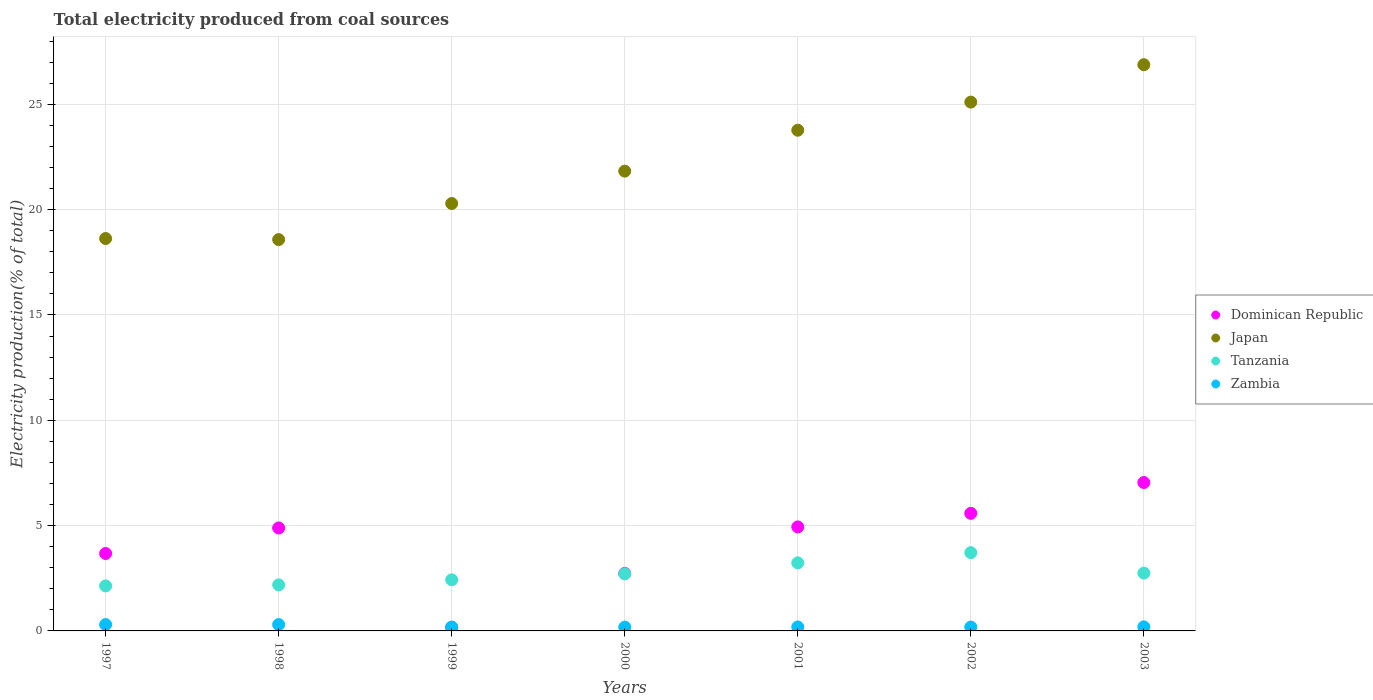How many different coloured dotlines are there?
Give a very brief answer. 4. Is the number of dotlines equal to the number of legend labels?
Provide a short and direct response. Yes. What is the total electricity produced in Dominican Republic in 1997?
Your response must be concise. 3.68. Across all years, what is the maximum total electricity produced in Dominican Republic?
Keep it short and to the point. 7.05. Across all years, what is the minimum total electricity produced in Zambia?
Your response must be concise. 0.18. What is the total total electricity produced in Dominican Republic in the graph?
Your answer should be very brief. 29.03. What is the difference between the total electricity produced in Dominican Republic in 1998 and that in 1999?
Give a very brief answer. 4.72. What is the difference between the total electricity produced in Zambia in 2002 and the total electricity produced in Japan in 2000?
Provide a short and direct response. -21.64. What is the average total electricity produced in Dominican Republic per year?
Offer a terse response. 4.15. In the year 2003, what is the difference between the total electricity produced in Zambia and total electricity produced in Dominican Republic?
Make the answer very short. -6.85. What is the ratio of the total electricity produced in Tanzania in 1998 to that in 2002?
Your answer should be very brief. 0.59. What is the difference between the highest and the second highest total electricity produced in Dominican Republic?
Ensure brevity in your answer.  1.46. What is the difference between the highest and the lowest total electricity produced in Tanzania?
Offer a very short reply. 1.58. Is the sum of the total electricity produced in Japan in 1998 and 2001 greater than the maximum total electricity produced in Tanzania across all years?
Your response must be concise. Yes. Is it the case that in every year, the sum of the total electricity produced in Tanzania and total electricity produced in Dominican Republic  is greater than the sum of total electricity produced in Zambia and total electricity produced in Japan?
Offer a very short reply. No. Is it the case that in every year, the sum of the total electricity produced in Dominican Republic and total electricity produced in Zambia  is greater than the total electricity produced in Tanzania?
Ensure brevity in your answer.  No. Is the total electricity produced in Tanzania strictly less than the total electricity produced in Dominican Republic over the years?
Offer a terse response. No. What is the difference between two consecutive major ticks on the Y-axis?
Your response must be concise. 5. Are the values on the major ticks of Y-axis written in scientific E-notation?
Offer a very short reply. No. Does the graph contain any zero values?
Your response must be concise. No. Does the graph contain grids?
Provide a succinct answer. Yes. How many legend labels are there?
Offer a very short reply. 4. How are the legend labels stacked?
Provide a short and direct response. Vertical. What is the title of the graph?
Offer a terse response. Total electricity produced from coal sources. Does "West Bank and Gaza" appear as one of the legend labels in the graph?
Give a very brief answer. No. What is the label or title of the X-axis?
Your response must be concise. Years. What is the label or title of the Y-axis?
Provide a succinct answer. Electricity production(% of total). What is the Electricity production(% of total) of Dominican Republic in 1997?
Provide a short and direct response. 3.68. What is the Electricity production(% of total) in Japan in 1997?
Keep it short and to the point. 18.63. What is the Electricity production(% of total) in Tanzania in 1997?
Keep it short and to the point. 2.14. What is the Electricity production(% of total) of Zambia in 1997?
Provide a short and direct response. 0.3. What is the Electricity production(% of total) of Dominican Republic in 1998?
Ensure brevity in your answer.  4.89. What is the Electricity production(% of total) of Japan in 1998?
Your answer should be very brief. 18.58. What is the Electricity production(% of total) in Tanzania in 1998?
Provide a succinct answer. 2.19. What is the Electricity production(% of total) of Zambia in 1998?
Provide a short and direct response. 0.3. What is the Electricity production(% of total) of Dominican Republic in 1999?
Offer a terse response. 0.17. What is the Electricity production(% of total) in Japan in 1999?
Offer a very short reply. 20.29. What is the Electricity production(% of total) in Tanzania in 1999?
Your answer should be compact. 2.43. What is the Electricity production(% of total) of Zambia in 1999?
Give a very brief answer. 0.18. What is the Electricity production(% of total) in Dominican Republic in 2000?
Make the answer very short. 2.73. What is the Electricity production(% of total) in Japan in 2000?
Keep it short and to the point. 21.83. What is the Electricity production(% of total) in Tanzania in 2000?
Offer a very short reply. 2.71. What is the Electricity production(% of total) of Zambia in 2000?
Give a very brief answer. 0.18. What is the Electricity production(% of total) in Dominican Republic in 2001?
Provide a succinct answer. 4.94. What is the Electricity production(% of total) of Japan in 2001?
Ensure brevity in your answer.  23.77. What is the Electricity production(% of total) in Tanzania in 2001?
Your answer should be very brief. 3.23. What is the Electricity production(% of total) of Zambia in 2001?
Provide a succinct answer. 0.19. What is the Electricity production(% of total) in Dominican Republic in 2002?
Your answer should be compact. 5.58. What is the Electricity production(% of total) in Japan in 2002?
Your response must be concise. 25.11. What is the Electricity production(% of total) of Tanzania in 2002?
Make the answer very short. 3.72. What is the Electricity production(% of total) of Zambia in 2002?
Provide a succinct answer. 0.18. What is the Electricity production(% of total) in Dominican Republic in 2003?
Give a very brief answer. 7.05. What is the Electricity production(% of total) of Japan in 2003?
Your answer should be very brief. 26.88. What is the Electricity production(% of total) in Tanzania in 2003?
Your response must be concise. 2.75. What is the Electricity production(% of total) of Zambia in 2003?
Offer a very short reply. 0.19. Across all years, what is the maximum Electricity production(% of total) of Dominican Republic?
Provide a succinct answer. 7.05. Across all years, what is the maximum Electricity production(% of total) in Japan?
Your answer should be compact. 26.88. Across all years, what is the maximum Electricity production(% of total) in Tanzania?
Provide a short and direct response. 3.72. Across all years, what is the maximum Electricity production(% of total) in Zambia?
Provide a short and direct response. 0.3. Across all years, what is the minimum Electricity production(% of total) in Dominican Republic?
Your answer should be compact. 0.17. Across all years, what is the minimum Electricity production(% of total) of Japan?
Provide a short and direct response. 18.58. Across all years, what is the minimum Electricity production(% of total) of Tanzania?
Provide a succinct answer. 2.14. Across all years, what is the minimum Electricity production(% of total) in Zambia?
Offer a very short reply. 0.18. What is the total Electricity production(% of total) of Dominican Republic in the graph?
Provide a succinct answer. 29.03. What is the total Electricity production(% of total) in Japan in the graph?
Your answer should be very brief. 155.08. What is the total Electricity production(% of total) of Tanzania in the graph?
Your answer should be very brief. 19.15. What is the total Electricity production(% of total) of Zambia in the graph?
Keep it short and to the point. 1.53. What is the difference between the Electricity production(% of total) of Dominican Republic in 1997 and that in 1998?
Make the answer very short. -1.21. What is the difference between the Electricity production(% of total) of Japan in 1997 and that in 1998?
Ensure brevity in your answer.  0.05. What is the difference between the Electricity production(% of total) in Tanzania in 1997 and that in 1998?
Your answer should be compact. -0.05. What is the difference between the Electricity production(% of total) in Zambia in 1997 and that in 1998?
Provide a succinct answer. -0. What is the difference between the Electricity production(% of total) of Dominican Republic in 1997 and that in 1999?
Offer a terse response. 3.51. What is the difference between the Electricity production(% of total) in Japan in 1997 and that in 1999?
Make the answer very short. -1.66. What is the difference between the Electricity production(% of total) of Tanzania in 1997 and that in 1999?
Give a very brief answer. -0.29. What is the difference between the Electricity production(% of total) in Zambia in 1997 and that in 1999?
Provide a succinct answer. 0.12. What is the difference between the Electricity production(% of total) in Dominican Republic in 1997 and that in 2000?
Give a very brief answer. 0.95. What is the difference between the Electricity production(% of total) in Japan in 1997 and that in 2000?
Offer a very short reply. -3.2. What is the difference between the Electricity production(% of total) of Tanzania in 1997 and that in 2000?
Your response must be concise. -0.57. What is the difference between the Electricity production(% of total) of Zambia in 1997 and that in 2000?
Your response must be concise. 0.12. What is the difference between the Electricity production(% of total) of Dominican Republic in 1997 and that in 2001?
Make the answer very short. -1.26. What is the difference between the Electricity production(% of total) of Japan in 1997 and that in 2001?
Ensure brevity in your answer.  -5.14. What is the difference between the Electricity production(% of total) of Tanzania in 1997 and that in 2001?
Give a very brief answer. -1.1. What is the difference between the Electricity production(% of total) in Zambia in 1997 and that in 2001?
Offer a very short reply. 0.11. What is the difference between the Electricity production(% of total) of Dominican Republic in 1997 and that in 2002?
Offer a terse response. -1.91. What is the difference between the Electricity production(% of total) of Japan in 1997 and that in 2002?
Offer a terse response. -6.48. What is the difference between the Electricity production(% of total) of Tanzania in 1997 and that in 2002?
Provide a short and direct response. -1.58. What is the difference between the Electricity production(% of total) in Zambia in 1997 and that in 2002?
Keep it short and to the point. 0.12. What is the difference between the Electricity production(% of total) in Dominican Republic in 1997 and that in 2003?
Your response must be concise. -3.37. What is the difference between the Electricity production(% of total) of Japan in 1997 and that in 2003?
Your response must be concise. -8.25. What is the difference between the Electricity production(% of total) of Tanzania in 1997 and that in 2003?
Ensure brevity in your answer.  -0.61. What is the difference between the Electricity production(% of total) in Zambia in 1997 and that in 2003?
Your answer should be compact. 0.11. What is the difference between the Electricity production(% of total) in Dominican Republic in 1998 and that in 1999?
Keep it short and to the point. 4.72. What is the difference between the Electricity production(% of total) of Japan in 1998 and that in 1999?
Ensure brevity in your answer.  -1.71. What is the difference between the Electricity production(% of total) in Tanzania in 1998 and that in 1999?
Ensure brevity in your answer.  -0.24. What is the difference between the Electricity production(% of total) in Zambia in 1998 and that in 1999?
Offer a very short reply. 0.12. What is the difference between the Electricity production(% of total) of Dominican Republic in 1998 and that in 2000?
Your answer should be very brief. 2.16. What is the difference between the Electricity production(% of total) of Japan in 1998 and that in 2000?
Keep it short and to the point. -3.25. What is the difference between the Electricity production(% of total) in Tanzania in 1998 and that in 2000?
Your response must be concise. -0.52. What is the difference between the Electricity production(% of total) of Zambia in 1998 and that in 2000?
Make the answer very short. 0.12. What is the difference between the Electricity production(% of total) in Dominican Republic in 1998 and that in 2001?
Your response must be concise. -0.05. What is the difference between the Electricity production(% of total) of Japan in 1998 and that in 2001?
Ensure brevity in your answer.  -5.19. What is the difference between the Electricity production(% of total) of Tanzania in 1998 and that in 2001?
Make the answer very short. -1.05. What is the difference between the Electricity production(% of total) in Zambia in 1998 and that in 2001?
Give a very brief answer. 0.11. What is the difference between the Electricity production(% of total) of Dominican Republic in 1998 and that in 2002?
Offer a terse response. -0.69. What is the difference between the Electricity production(% of total) in Japan in 1998 and that in 2002?
Offer a terse response. -6.53. What is the difference between the Electricity production(% of total) in Tanzania in 1998 and that in 2002?
Offer a very short reply. -1.53. What is the difference between the Electricity production(% of total) in Zambia in 1998 and that in 2002?
Give a very brief answer. 0.12. What is the difference between the Electricity production(% of total) of Dominican Republic in 1998 and that in 2003?
Ensure brevity in your answer.  -2.16. What is the difference between the Electricity production(% of total) in Japan in 1998 and that in 2003?
Make the answer very short. -8.3. What is the difference between the Electricity production(% of total) in Tanzania in 1998 and that in 2003?
Ensure brevity in your answer.  -0.56. What is the difference between the Electricity production(% of total) of Zambia in 1998 and that in 2003?
Keep it short and to the point. 0.11. What is the difference between the Electricity production(% of total) in Dominican Republic in 1999 and that in 2000?
Give a very brief answer. -2.56. What is the difference between the Electricity production(% of total) in Japan in 1999 and that in 2000?
Make the answer very short. -1.54. What is the difference between the Electricity production(% of total) of Tanzania in 1999 and that in 2000?
Keep it short and to the point. -0.28. What is the difference between the Electricity production(% of total) in Zambia in 1999 and that in 2000?
Give a very brief answer. 0. What is the difference between the Electricity production(% of total) of Dominican Republic in 1999 and that in 2001?
Your response must be concise. -4.77. What is the difference between the Electricity production(% of total) of Japan in 1999 and that in 2001?
Your response must be concise. -3.48. What is the difference between the Electricity production(% of total) in Tanzania in 1999 and that in 2001?
Provide a short and direct response. -0.8. What is the difference between the Electricity production(% of total) of Zambia in 1999 and that in 2001?
Give a very brief answer. -0.01. What is the difference between the Electricity production(% of total) of Dominican Republic in 1999 and that in 2002?
Offer a terse response. -5.41. What is the difference between the Electricity production(% of total) in Japan in 1999 and that in 2002?
Your answer should be compact. -4.81. What is the difference between the Electricity production(% of total) in Tanzania in 1999 and that in 2002?
Offer a very short reply. -1.29. What is the difference between the Electricity production(% of total) of Zambia in 1999 and that in 2002?
Your response must be concise. -0. What is the difference between the Electricity production(% of total) of Dominican Republic in 1999 and that in 2003?
Your answer should be compact. -6.88. What is the difference between the Electricity production(% of total) in Japan in 1999 and that in 2003?
Give a very brief answer. -6.59. What is the difference between the Electricity production(% of total) of Tanzania in 1999 and that in 2003?
Ensure brevity in your answer.  -0.32. What is the difference between the Electricity production(% of total) of Zambia in 1999 and that in 2003?
Offer a very short reply. -0.01. What is the difference between the Electricity production(% of total) in Dominican Republic in 2000 and that in 2001?
Provide a short and direct response. -2.21. What is the difference between the Electricity production(% of total) in Japan in 2000 and that in 2001?
Give a very brief answer. -1.94. What is the difference between the Electricity production(% of total) in Tanzania in 2000 and that in 2001?
Give a very brief answer. -0.52. What is the difference between the Electricity production(% of total) in Zambia in 2000 and that in 2001?
Provide a short and direct response. -0.01. What is the difference between the Electricity production(% of total) in Dominican Republic in 2000 and that in 2002?
Your answer should be compact. -2.85. What is the difference between the Electricity production(% of total) of Japan in 2000 and that in 2002?
Provide a short and direct response. -3.28. What is the difference between the Electricity production(% of total) of Tanzania in 2000 and that in 2002?
Ensure brevity in your answer.  -1.01. What is the difference between the Electricity production(% of total) in Zambia in 2000 and that in 2002?
Give a very brief answer. -0. What is the difference between the Electricity production(% of total) of Dominican Republic in 2000 and that in 2003?
Offer a terse response. -4.32. What is the difference between the Electricity production(% of total) in Japan in 2000 and that in 2003?
Provide a short and direct response. -5.05. What is the difference between the Electricity production(% of total) in Tanzania in 2000 and that in 2003?
Your answer should be compact. -0.04. What is the difference between the Electricity production(% of total) of Zambia in 2000 and that in 2003?
Give a very brief answer. -0.01. What is the difference between the Electricity production(% of total) in Dominican Republic in 2001 and that in 2002?
Your answer should be compact. -0.64. What is the difference between the Electricity production(% of total) in Japan in 2001 and that in 2002?
Your answer should be very brief. -1.33. What is the difference between the Electricity production(% of total) of Tanzania in 2001 and that in 2002?
Provide a succinct answer. -0.48. What is the difference between the Electricity production(% of total) of Zambia in 2001 and that in 2002?
Provide a short and direct response. 0. What is the difference between the Electricity production(% of total) of Dominican Republic in 2001 and that in 2003?
Offer a very short reply. -2.11. What is the difference between the Electricity production(% of total) of Japan in 2001 and that in 2003?
Offer a very short reply. -3.11. What is the difference between the Electricity production(% of total) in Tanzania in 2001 and that in 2003?
Ensure brevity in your answer.  0.49. What is the difference between the Electricity production(% of total) of Zambia in 2001 and that in 2003?
Provide a short and direct response. -0. What is the difference between the Electricity production(% of total) of Dominican Republic in 2002 and that in 2003?
Your answer should be compact. -1.46. What is the difference between the Electricity production(% of total) of Japan in 2002 and that in 2003?
Keep it short and to the point. -1.78. What is the difference between the Electricity production(% of total) of Tanzania in 2002 and that in 2003?
Your answer should be very brief. 0.97. What is the difference between the Electricity production(% of total) in Zambia in 2002 and that in 2003?
Your response must be concise. -0.01. What is the difference between the Electricity production(% of total) in Dominican Republic in 1997 and the Electricity production(% of total) in Japan in 1998?
Provide a succinct answer. -14.9. What is the difference between the Electricity production(% of total) in Dominican Republic in 1997 and the Electricity production(% of total) in Tanzania in 1998?
Give a very brief answer. 1.49. What is the difference between the Electricity production(% of total) in Dominican Republic in 1997 and the Electricity production(% of total) in Zambia in 1998?
Your response must be concise. 3.37. What is the difference between the Electricity production(% of total) in Japan in 1997 and the Electricity production(% of total) in Tanzania in 1998?
Make the answer very short. 16.44. What is the difference between the Electricity production(% of total) of Japan in 1997 and the Electricity production(% of total) of Zambia in 1998?
Provide a short and direct response. 18.33. What is the difference between the Electricity production(% of total) in Tanzania in 1997 and the Electricity production(% of total) in Zambia in 1998?
Keep it short and to the point. 1.83. What is the difference between the Electricity production(% of total) in Dominican Republic in 1997 and the Electricity production(% of total) in Japan in 1999?
Give a very brief answer. -16.61. What is the difference between the Electricity production(% of total) of Dominican Republic in 1997 and the Electricity production(% of total) of Tanzania in 1999?
Offer a terse response. 1.25. What is the difference between the Electricity production(% of total) in Dominican Republic in 1997 and the Electricity production(% of total) in Zambia in 1999?
Make the answer very short. 3.5. What is the difference between the Electricity production(% of total) in Japan in 1997 and the Electricity production(% of total) in Tanzania in 1999?
Keep it short and to the point. 16.2. What is the difference between the Electricity production(% of total) of Japan in 1997 and the Electricity production(% of total) of Zambia in 1999?
Your answer should be very brief. 18.45. What is the difference between the Electricity production(% of total) of Tanzania in 1997 and the Electricity production(% of total) of Zambia in 1999?
Provide a succinct answer. 1.96. What is the difference between the Electricity production(% of total) in Dominican Republic in 1997 and the Electricity production(% of total) in Japan in 2000?
Keep it short and to the point. -18.15. What is the difference between the Electricity production(% of total) in Dominican Republic in 1997 and the Electricity production(% of total) in Tanzania in 2000?
Your answer should be very brief. 0.97. What is the difference between the Electricity production(% of total) in Dominican Republic in 1997 and the Electricity production(% of total) in Zambia in 2000?
Your answer should be compact. 3.5. What is the difference between the Electricity production(% of total) in Japan in 1997 and the Electricity production(% of total) in Tanzania in 2000?
Give a very brief answer. 15.92. What is the difference between the Electricity production(% of total) of Japan in 1997 and the Electricity production(% of total) of Zambia in 2000?
Provide a succinct answer. 18.45. What is the difference between the Electricity production(% of total) of Tanzania in 1997 and the Electricity production(% of total) of Zambia in 2000?
Provide a succinct answer. 1.96. What is the difference between the Electricity production(% of total) of Dominican Republic in 1997 and the Electricity production(% of total) of Japan in 2001?
Provide a succinct answer. -20.09. What is the difference between the Electricity production(% of total) in Dominican Republic in 1997 and the Electricity production(% of total) in Tanzania in 2001?
Provide a short and direct response. 0.44. What is the difference between the Electricity production(% of total) in Dominican Republic in 1997 and the Electricity production(% of total) in Zambia in 2001?
Give a very brief answer. 3.49. What is the difference between the Electricity production(% of total) of Japan in 1997 and the Electricity production(% of total) of Tanzania in 2001?
Make the answer very short. 15.4. What is the difference between the Electricity production(% of total) in Japan in 1997 and the Electricity production(% of total) in Zambia in 2001?
Offer a terse response. 18.44. What is the difference between the Electricity production(% of total) of Tanzania in 1997 and the Electricity production(% of total) of Zambia in 2001?
Give a very brief answer. 1.95. What is the difference between the Electricity production(% of total) in Dominican Republic in 1997 and the Electricity production(% of total) in Japan in 2002?
Give a very brief answer. -21.43. What is the difference between the Electricity production(% of total) of Dominican Republic in 1997 and the Electricity production(% of total) of Tanzania in 2002?
Keep it short and to the point. -0.04. What is the difference between the Electricity production(% of total) of Dominican Republic in 1997 and the Electricity production(% of total) of Zambia in 2002?
Offer a terse response. 3.49. What is the difference between the Electricity production(% of total) of Japan in 1997 and the Electricity production(% of total) of Tanzania in 2002?
Ensure brevity in your answer.  14.91. What is the difference between the Electricity production(% of total) of Japan in 1997 and the Electricity production(% of total) of Zambia in 2002?
Ensure brevity in your answer.  18.44. What is the difference between the Electricity production(% of total) in Tanzania in 1997 and the Electricity production(% of total) in Zambia in 2002?
Provide a short and direct response. 1.95. What is the difference between the Electricity production(% of total) of Dominican Republic in 1997 and the Electricity production(% of total) of Japan in 2003?
Your answer should be very brief. -23.2. What is the difference between the Electricity production(% of total) in Dominican Republic in 1997 and the Electricity production(% of total) in Tanzania in 2003?
Your response must be concise. 0.93. What is the difference between the Electricity production(% of total) in Dominican Republic in 1997 and the Electricity production(% of total) in Zambia in 2003?
Provide a succinct answer. 3.48. What is the difference between the Electricity production(% of total) in Japan in 1997 and the Electricity production(% of total) in Tanzania in 2003?
Your answer should be very brief. 15.88. What is the difference between the Electricity production(% of total) in Japan in 1997 and the Electricity production(% of total) in Zambia in 2003?
Your answer should be very brief. 18.44. What is the difference between the Electricity production(% of total) in Tanzania in 1997 and the Electricity production(% of total) in Zambia in 2003?
Give a very brief answer. 1.94. What is the difference between the Electricity production(% of total) of Dominican Republic in 1998 and the Electricity production(% of total) of Japan in 1999?
Provide a succinct answer. -15.4. What is the difference between the Electricity production(% of total) of Dominican Republic in 1998 and the Electricity production(% of total) of Tanzania in 1999?
Give a very brief answer. 2.46. What is the difference between the Electricity production(% of total) in Dominican Republic in 1998 and the Electricity production(% of total) in Zambia in 1999?
Offer a terse response. 4.71. What is the difference between the Electricity production(% of total) in Japan in 1998 and the Electricity production(% of total) in Tanzania in 1999?
Your answer should be very brief. 16.15. What is the difference between the Electricity production(% of total) in Japan in 1998 and the Electricity production(% of total) in Zambia in 1999?
Make the answer very short. 18.4. What is the difference between the Electricity production(% of total) in Tanzania in 1998 and the Electricity production(% of total) in Zambia in 1999?
Offer a very short reply. 2.01. What is the difference between the Electricity production(% of total) of Dominican Republic in 1998 and the Electricity production(% of total) of Japan in 2000?
Keep it short and to the point. -16.94. What is the difference between the Electricity production(% of total) of Dominican Republic in 1998 and the Electricity production(% of total) of Tanzania in 2000?
Your response must be concise. 2.18. What is the difference between the Electricity production(% of total) of Dominican Republic in 1998 and the Electricity production(% of total) of Zambia in 2000?
Make the answer very short. 4.71. What is the difference between the Electricity production(% of total) of Japan in 1998 and the Electricity production(% of total) of Tanzania in 2000?
Make the answer very short. 15.87. What is the difference between the Electricity production(% of total) in Japan in 1998 and the Electricity production(% of total) in Zambia in 2000?
Your response must be concise. 18.4. What is the difference between the Electricity production(% of total) of Tanzania in 1998 and the Electricity production(% of total) of Zambia in 2000?
Provide a short and direct response. 2.01. What is the difference between the Electricity production(% of total) in Dominican Republic in 1998 and the Electricity production(% of total) in Japan in 2001?
Give a very brief answer. -18.88. What is the difference between the Electricity production(% of total) in Dominican Republic in 1998 and the Electricity production(% of total) in Tanzania in 2001?
Keep it short and to the point. 1.66. What is the difference between the Electricity production(% of total) in Dominican Republic in 1998 and the Electricity production(% of total) in Zambia in 2001?
Give a very brief answer. 4.7. What is the difference between the Electricity production(% of total) of Japan in 1998 and the Electricity production(% of total) of Tanzania in 2001?
Your answer should be compact. 15.35. What is the difference between the Electricity production(% of total) in Japan in 1998 and the Electricity production(% of total) in Zambia in 2001?
Provide a short and direct response. 18.39. What is the difference between the Electricity production(% of total) in Tanzania in 1998 and the Electricity production(% of total) in Zambia in 2001?
Provide a succinct answer. 2. What is the difference between the Electricity production(% of total) in Dominican Republic in 1998 and the Electricity production(% of total) in Japan in 2002?
Your answer should be very brief. -20.22. What is the difference between the Electricity production(% of total) of Dominican Republic in 1998 and the Electricity production(% of total) of Tanzania in 2002?
Give a very brief answer. 1.17. What is the difference between the Electricity production(% of total) in Dominican Republic in 1998 and the Electricity production(% of total) in Zambia in 2002?
Your response must be concise. 4.7. What is the difference between the Electricity production(% of total) of Japan in 1998 and the Electricity production(% of total) of Tanzania in 2002?
Offer a terse response. 14.86. What is the difference between the Electricity production(% of total) of Japan in 1998 and the Electricity production(% of total) of Zambia in 2002?
Keep it short and to the point. 18.39. What is the difference between the Electricity production(% of total) of Tanzania in 1998 and the Electricity production(% of total) of Zambia in 2002?
Ensure brevity in your answer.  2. What is the difference between the Electricity production(% of total) of Dominican Republic in 1998 and the Electricity production(% of total) of Japan in 2003?
Offer a terse response. -21.99. What is the difference between the Electricity production(% of total) of Dominican Republic in 1998 and the Electricity production(% of total) of Tanzania in 2003?
Keep it short and to the point. 2.14. What is the difference between the Electricity production(% of total) of Dominican Republic in 1998 and the Electricity production(% of total) of Zambia in 2003?
Provide a succinct answer. 4.7. What is the difference between the Electricity production(% of total) of Japan in 1998 and the Electricity production(% of total) of Tanzania in 2003?
Give a very brief answer. 15.83. What is the difference between the Electricity production(% of total) in Japan in 1998 and the Electricity production(% of total) in Zambia in 2003?
Offer a very short reply. 18.39. What is the difference between the Electricity production(% of total) in Tanzania in 1998 and the Electricity production(% of total) in Zambia in 2003?
Provide a short and direct response. 1.99. What is the difference between the Electricity production(% of total) in Dominican Republic in 1999 and the Electricity production(% of total) in Japan in 2000?
Provide a short and direct response. -21.66. What is the difference between the Electricity production(% of total) of Dominican Republic in 1999 and the Electricity production(% of total) of Tanzania in 2000?
Your answer should be compact. -2.54. What is the difference between the Electricity production(% of total) in Dominican Republic in 1999 and the Electricity production(% of total) in Zambia in 2000?
Provide a succinct answer. -0.01. What is the difference between the Electricity production(% of total) of Japan in 1999 and the Electricity production(% of total) of Tanzania in 2000?
Offer a terse response. 17.58. What is the difference between the Electricity production(% of total) in Japan in 1999 and the Electricity production(% of total) in Zambia in 2000?
Provide a short and direct response. 20.11. What is the difference between the Electricity production(% of total) of Tanzania in 1999 and the Electricity production(% of total) of Zambia in 2000?
Make the answer very short. 2.25. What is the difference between the Electricity production(% of total) in Dominican Republic in 1999 and the Electricity production(% of total) in Japan in 2001?
Offer a terse response. -23.6. What is the difference between the Electricity production(% of total) of Dominican Republic in 1999 and the Electricity production(% of total) of Tanzania in 2001?
Make the answer very short. -3.06. What is the difference between the Electricity production(% of total) of Dominican Republic in 1999 and the Electricity production(% of total) of Zambia in 2001?
Keep it short and to the point. -0.02. What is the difference between the Electricity production(% of total) in Japan in 1999 and the Electricity production(% of total) in Tanzania in 2001?
Your answer should be compact. 17.06. What is the difference between the Electricity production(% of total) of Japan in 1999 and the Electricity production(% of total) of Zambia in 2001?
Provide a short and direct response. 20.1. What is the difference between the Electricity production(% of total) in Tanzania in 1999 and the Electricity production(% of total) in Zambia in 2001?
Keep it short and to the point. 2.24. What is the difference between the Electricity production(% of total) in Dominican Republic in 1999 and the Electricity production(% of total) in Japan in 2002?
Your answer should be very brief. -24.94. What is the difference between the Electricity production(% of total) of Dominican Republic in 1999 and the Electricity production(% of total) of Tanzania in 2002?
Offer a terse response. -3.55. What is the difference between the Electricity production(% of total) in Dominican Republic in 1999 and the Electricity production(% of total) in Zambia in 2002?
Offer a terse response. -0.01. What is the difference between the Electricity production(% of total) in Japan in 1999 and the Electricity production(% of total) in Tanzania in 2002?
Give a very brief answer. 16.58. What is the difference between the Electricity production(% of total) of Japan in 1999 and the Electricity production(% of total) of Zambia in 2002?
Offer a terse response. 20.11. What is the difference between the Electricity production(% of total) in Tanzania in 1999 and the Electricity production(% of total) in Zambia in 2002?
Provide a short and direct response. 2.24. What is the difference between the Electricity production(% of total) in Dominican Republic in 1999 and the Electricity production(% of total) in Japan in 2003?
Your answer should be compact. -26.71. What is the difference between the Electricity production(% of total) of Dominican Republic in 1999 and the Electricity production(% of total) of Tanzania in 2003?
Your response must be concise. -2.58. What is the difference between the Electricity production(% of total) in Dominican Republic in 1999 and the Electricity production(% of total) in Zambia in 2003?
Ensure brevity in your answer.  -0.02. What is the difference between the Electricity production(% of total) of Japan in 1999 and the Electricity production(% of total) of Tanzania in 2003?
Ensure brevity in your answer.  17.55. What is the difference between the Electricity production(% of total) of Japan in 1999 and the Electricity production(% of total) of Zambia in 2003?
Provide a succinct answer. 20.1. What is the difference between the Electricity production(% of total) of Tanzania in 1999 and the Electricity production(% of total) of Zambia in 2003?
Provide a short and direct response. 2.23. What is the difference between the Electricity production(% of total) in Dominican Republic in 2000 and the Electricity production(% of total) in Japan in 2001?
Your response must be concise. -21.04. What is the difference between the Electricity production(% of total) in Dominican Republic in 2000 and the Electricity production(% of total) in Tanzania in 2001?
Offer a terse response. -0.5. What is the difference between the Electricity production(% of total) of Dominican Republic in 2000 and the Electricity production(% of total) of Zambia in 2001?
Keep it short and to the point. 2.54. What is the difference between the Electricity production(% of total) in Japan in 2000 and the Electricity production(% of total) in Tanzania in 2001?
Ensure brevity in your answer.  18.6. What is the difference between the Electricity production(% of total) in Japan in 2000 and the Electricity production(% of total) in Zambia in 2001?
Your answer should be very brief. 21.64. What is the difference between the Electricity production(% of total) of Tanzania in 2000 and the Electricity production(% of total) of Zambia in 2001?
Give a very brief answer. 2.52. What is the difference between the Electricity production(% of total) of Dominican Republic in 2000 and the Electricity production(% of total) of Japan in 2002?
Offer a terse response. -22.38. What is the difference between the Electricity production(% of total) in Dominican Republic in 2000 and the Electricity production(% of total) in Tanzania in 2002?
Offer a terse response. -0.99. What is the difference between the Electricity production(% of total) of Dominican Republic in 2000 and the Electricity production(% of total) of Zambia in 2002?
Offer a terse response. 2.54. What is the difference between the Electricity production(% of total) in Japan in 2000 and the Electricity production(% of total) in Tanzania in 2002?
Your response must be concise. 18.11. What is the difference between the Electricity production(% of total) in Japan in 2000 and the Electricity production(% of total) in Zambia in 2002?
Provide a short and direct response. 21.64. What is the difference between the Electricity production(% of total) in Tanzania in 2000 and the Electricity production(% of total) in Zambia in 2002?
Ensure brevity in your answer.  2.53. What is the difference between the Electricity production(% of total) of Dominican Republic in 2000 and the Electricity production(% of total) of Japan in 2003?
Provide a short and direct response. -24.15. What is the difference between the Electricity production(% of total) of Dominican Republic in 2000 and the Electricity production(% of total) of Tanzania in 2003?
Make the answer very short. -0.02. What is the difference between the Electricity production(% of total) in Dominican Republic in 2000 and the Electricity production(% of total) in Zambia in 2003?
Make the answer very short. 2.54. What is the difference between the Electricity production(% of total) in Japan in 2000 and the Electricity production(% of total) in Tanzania in 2003?
Your answer should be compact. 19.08. What is the difference between the Electricity production(% of total) of Japan in 2000 and the Electricity production(% of total) of Zambia in 2003?
Provide a succinct answer. 21.64. What is the difference between the Electricity production(% of total) of Tanzania in 2000 and the Electricity production(% of total) of Zambia in 2003?
Make the answer very short. 2.52. What is the difference between the Electricity production(% of total) of Dominican Republic in 2001 and the Electricity production(% of total) of Japan in 2002?
Offer a very short reply. -20.17. What is the difference between the Electricity production(% of total) in Dominican Republic in 2001 and the Electricity production(% of total) in Tanzania in 2002?
Your answer should be compact. 1.22. What is the difference between the Electricity production(% of total) of Dominican Republic in 2001 and the Electricity production(% of total) of Zambia in 2002?
Your response must be concise. 4.75. What is the difference between the Electricity production(% of total) of Japan in 2001 and the Electricity production(% of total) of Tanzania in 2002?
Your response must be concise. 20.06. What is the difference between the Electricity production(% of total) of Japan in 2001 and the Electricity production(% of total) of Zambia in 2002?
Ensure brevity in your answer.  23.59. What is the difference between the Electricity production(% of total) in Tanzania in 2001 and the Electricity production(% of total) in Zambia in 2002?
Give a very brief answer. 3.05. What is the difference between the Electricity production(% of total) of Dominican Republic in 2001 and the Electricity production(% of total) of Japan in 2003?
Keep it short and to the point. -21.94. What is the difference between the Electricity production(% of total) of Dominican Republic in 2001 and the Electricity production(% of total) of Tanzania in 2003?
Your response must be concise. 2.19. What is the difference between the Electricity production(% of total) of Dominican Republic in 2001 and the Electricity production(% of total) of Zambia in 2003?
Keep it short and to the point. 4.75. What is the difference between the Electricity production(% of total) of Japan in 2001 and the Electricity production(% of total) of Tanzania in 2003?
Give a very brief answer. 21.03. What is the difference between the Electricity production(% of total) of Japan in 2001 and the Electricity production(% of total) of Zambia in 2003?
Make the answer very short. 23.58. What is the difference between the Electricity production(% of total) of Tanzania in 2001 and the Electricity production(% of total) of Zambia in 2003?
Your answer should be compact. 3.04. What is the difference between the Electricity production(% of total) in Dominican Republic in 2002 and the Electricity production(% of total) in Japan in 2003?
Provide a short and direct response. -21.3. What is the difference between the Electricity production(% of total) of Dominican Republic in 2002 and the Electricity production(% of total) of Tanzania in 2003?
Make the answer very short. 2.84. What is the difference between the Electricity production(% of total) of Dominican Republic in 2002 and the Electricity production(% of total) of Zambia in 2003?
Provide a succinct answer. 5.39. What is the difference between the Electricity production(% of total) in Japan in 2002 and the Electricity production(% of total) in Tanzania in 2003?
Provide a short and direct response. 22.36. What is the difference between the Electricity production(% of total) of Japan in 2002 and the Electricity production(% of total) of Zambia in 2003?
Your response must be concise. 24.91. What is the difference between the Electricity production(% of total) in Tanzania in 2002 and the Electricity production(% of total) in Zambia in 2003?
Make the answer very short. 3.52. What is the average Electricity production(% of total) in Dominican Republic per year?
Offer a terse response. 4.15. What is the average Electricity production(% of total) in Japan per year?
Provide a short and direct response. 22.15. What is the average Electricity production(% of total) of Tanzania per year?
Your answer should be very brief. 2.74. What is the average Electricity production(% of total) in Zambia per year?
Your answer should be very brief. 0.22. In the year 1997, what is the difference between the Electricity production(% of total) in Dominican Republic and Electricity production(% of total) in Japan?
Your answer should be compact. -14.95. In the year 1997, what is the difference between the Electricity production(% of total) of Dominican Republic and Electricity production(% of total) of Tanzania?
Provide a short and direct response. 1.54. In the year 1997, what is the difference between the Electricity production(% of total) of Dominican Republic and Electricity production(% of total) of Zambia?
Ensure brevity in your answer.  3.37. In the year 1997, what is the difference between the Electricity production(% of total) in Japan and Electricity production(% of total) in Tanzania?
Keep it short and to the point. 16.49. In the year 1997, what is the difference between the Electricity production(% of total) of Japan and Electricity production(% of total) of Zambia?
Your answer should be very brief. 18.33. In the year 1997, what is the difference between the Electricity production(% of total) in Tanzania and Electricity production(% of total) in Zambia?
Your response must be concise. 1.83. In the year 1998, what is the difference between the Electricity production(% of total) in Dominican Republic and Electricity production(% of total) in Japan?
Keep it short and to the point. -13.69. In the year 1998, what is the difference between the Electricity production(% of total) in Dominican Republic and Electricity production(% of total) in Tanzania?
Your answer should be compact. 2.7. In the year 1998, what is the difference between the Electricity production(% of total) of Dominican Republic and Electricity production(% of total) of Zambia?
Offer a very short reply. 4.58. In the year 1998, what is the difference between the Electricity production(% of total) of Japan and Electricity production(% of total) of Tanzania?
Your answer should be very brief. 16.39. In the year 1998, what is the difference between the Electricity production(% of total) of Japan and Electricity production(% of total) of Zambia?
Ensure brevity in your answer.  18.28. In the year 1998, what is the difference between the Electricity production(% of total) of Tanzania and Electricity production(% of total) of Zambia?
Offer a very short reply. 1.88. In the year 1999, what is the difference between the Electricity production(% of total) of Dominican Republic and Electricity production(% of total) of Japan?
Offer a very short reply. -20.12. In the year 1999, what is the difference between the Electricity production(% of total) in Dominican Republic and Electricity production(% of total) in Tanzania?
Make the answer very short. -2.26. In the year 1999, what is the difference between the Electricity production(% of total) in Dominican Republic and Electricity production(% of total) in Zambia?
Give a very brief answer. -0.01. In the year 1999, what is the difference between the Electricity production(% of total) of Japan and Electricity production(% of total) of Tanzania?
Give a very brief answer. 17.86. In the year 1999, what is the difference between the Electricity production(% of total) of Japan and Electricity production(% of total) of Zambia?
Offer a very short reply. 20.11. In the year 1999, what is the difference between the Electricity production(% of total) of Tanzania and Electricity production(% of total) of Zambia?
Give a very brief answer. 2.25. In the year 2000, what is the difference between the Electricity production(% of total) of Dominican Republic and Electricity production(% of total) of Japan?
Provide a succinct answer. -19.1. In the year 2000, what is the difference between the Electricity production(% of total) of Dominican Republic and Electricity production(% of total) of Tanzania?
Your response must be concise. 0.02. In the year 2000, what is the difference between the Electricity production(% of total) of Dominican Republic and Electricity production(% of total) of Zambia?
Give a very brief answer. 2.55. In the year 2000, what is the difference between the Electricity production(% of total) of Japan and Electricity production(% of total) of Tanzania?
Make the answer very short. 19.12. In the year 2000, what is the difference between the Electricity production(% of total) in Japan and Electricity production(% of total) in Zambia?
Make the answer very short. 21.65. In the year 2000, what is the difference between the Electricity production(% of total) in Tanzania and Electricity production(% of total) in Zambia?
Keep it short and to the point. 2.53. In the year 2001, what is the difference between the Electricity production(% of total) in Dominican Republic and Electricity production(% of total) in Japan?
Keep it short and to the point. -18.83. In the year 2001, what is the difference between the Electricity production(% of total) in Dominican Republic and Electricity production(% of total) in Tanzania?
Offer a terse response. 1.71. In the year 2001, what is the difference between the Electricity production(% of total) of Dominican Republic and Electricity production(% of total) of Zambia?
Provide a short and direct response. 4.75. In the year 2001, what is the difference between the Electricity production(% of total) of Japan and Electricity production(% of total) of Tanzania?
Your answer should be very brief. 20.54. In the year 2001, what is the difference between the Electricity production(% of total) in Japan and Electricity production(% of total) in Zambia?
Give a very brief answer. 23.58. In the year 2001, what is the difference between the Electricity production(% of total) in Tanzania and Electricity production(% of total) in Zambia?
Make the answer very short. 3.04. In the year 2002, what is the difference between the Electricity production(% of total) in Dominican Republic and Electricity production(% of total) in Japan?
Make the answer very short. -19.52. In the year 2002, what is the difference between the Electricity production(% of total) in Dominican Republic and Electricity production(% of total) in Tanzania?
Offer a very short reply. 1.87. In the year 2002, what is the difference between the Electricity production(% of total) of Dominican Republic and Electricity production(% of total) of Zambia?
Ensure brevity in your answer.  5.4. In the year 2002, what is the difference between the Electricity production(% of total) of Japan and Electricity production(% of total) of Tanzania?
Provide a short and direct response. 21.39. In the year 2002, what is the difference between the Electricity production(% of total) in Japan and Electricity production(% of total) in Zambia?
Provide a succinct answer. 24.92. In the year 2002, what is the difference between the Electricity production(% of total) of Tanzania and Electricity production(% of total) of Zambia?
Give a very brief answer. 3.53. In the year 2003, what is the difference between the Electricity production(% of total) in Dominican Republic and Electricity production(% of total) in Japan?
Provide a short and direct response. -19.84. In the year 2003, what is the difference between the Electricity production(% of total) of Dominican Republic and Electricity production(% of total) of Tanzania?
Your response must be concise. 4.3. In the year 2003, what is the difference between the Electricity production(% of total) of Dominican Republic and Electricity production(% of total) of Zambia?
Your answer should be very brief. 6.85. In the year 2003, what is the difference between the Electricity production(% of total) in Japan and Electricity production(% of total) in Tanzania?
Offer a very short reply. 24.14. In the year 2003, what is the difference between the Electricity production(% of total) in Japan and Electricity production(% of total) in Zambia?
Provide a short and direct response. 26.69. In the year 2003, what is the difference between the Electricity production(% of total) of Tanzania and Electricity production(% of total) of Zambia?
Your response must be concise. 2.55. What is the ratio of the Electricity production(% of total) of Dominican Republic in 1997 to that in 1998?
Your response must be concise. 0.75. What is the ratio of the Electricity production(% of total) of Japan in 1997 to that in 1998?
Give a very brief answer. 1. What is the ratio of the Electricity production(% of total) of Tanzania in 1997 to that in 1998?
Make the answer very short. 0.98. What is the ratio of the Electricity production(% of total) of Dominican Republic in 1997 to that in 1999?
Provide a succinct answer. 21.71. What is the ratio of the Electricity production(% of total) in Japan in 1997 to that in 1999?
Offer a very short reply. 0.92. What is the ratio of the Electricity production(% of total) in Tanzania in 1997 to that in 1999?
Provide a succinct answer. 0.88. What is the ratio of the Electricity production(% of total) in Zambia in 1997 to that in 1999?
Ensure brevity in your answer.  1.68. What is the ratio of the Electricity production(% of total) of Dominican Republic in 1997 to that in 2000?
Ensure brevity in your answer.  1.35. What is the ratio of the Electricity production(% of total) in Japan in 1997 to that in 2000?
Ensure brevity in your answer.  0.85. What is the ratio of the Electricity production(% of total) in Tanzania in 1997 to that in 2000?
Your answer should be very brief. 0.79. What is the ratio of the Electricity production(% of total) in Zambia in 1997 to that in 2000?
Provide a short and direct response. 1.68. What is the ratio of the Electricity production(% of total) in Dominican Republic in 1997 to that in 2001?
Keep it short and to the point. 0.74. What is the ratio of the Electricity production(% of total) in Japan in 1997 to that in 2001?
Ensure brevity in your answer.  0.78. What is the ratio of the Electricity production(% of total) of Tanzania in 1997 to that in 2001?
Give a very brief answer. 0.66. What is the ratio of the Electricity production(% of total) of Zambia in 1997 to that in 2001?
Your answer should be very brief. 1.6. What is the ratio of the Electricity production(% of total) of Dominican Republic in 1997 to that in 2002?
Give a very brief answer. 0.66. What is the ratio of the Electricity production(% of total) of Japan in 1997 to that in 2002?
Keep it short and to the point. 0.74. What is the ratio of the Electricity production(% of total) in Tanzania in 1997 to that in 2002?
Keep it short and to the point. 0.57. What is the ratio of the Electricity production(% of total) in Zambia in 1997 to that in 2002?
Provide a succinct answer. 1.64. What is the ratio of the Electricity production(% of total) of Dominican Republic in 1997 to that in 2003?
Your response must be concise. 0.52. What is the ratio of the Electricity production(% of total) in Japan in 1997 to that in 2003?
Offer a very short reply. 0.69. What is the ratio of the Electricity production(% of total) in Tanzania in 1997 to that in 2003?
Make the answer very short. 0.78. What is the ratio of the Electricity production(% of total) of Zambia in 1997 to that in 2003?
Give a very brief answer. 1.57. What is the ratio of the Electricity production(% of total) of Dominican Republic in 1998 to that in 1999?
Make the answer very short. 28.86. What is the ratio of the Electricity production(% of total) of Japan in 1998 to that in 1999?
Offer a terse response. 0.92. What is the ratio of the Electricity production(% of total) in Tanzania in 1998 to that in 1999?
Provide a short and direct response. 0.9. What is the ratio of the Electricity production(% of total) in Zambia in 1998 to that in 1999?
Give a very brief answer. 1.68. What is the ratio of the Electricity production(% of total) of Dominican Republic in 1998 to that in 2000?
Keep it short and to the point. 1.79. What is the ratio of the Electricity production(% of total) of Japan in 1998 to that in 2000?
Offer a very short reply. 0.85. What is the ratio of the Electricity production(% of total) of Tanzania in 1998 to that in 2000?
Give a very brief answer. 0.81. What is the ratio of the Electricity production(% of total) of Zambia in 1998 to that in 2000?
Your response must be concise. 1.69. What is the ratio of the Electricity production(% of total) of Japan in 1998 to that in 2001?
Provide a short and direct response. 0.78. What is the ratio of the Electricity production(% of total) in Tanzania in 1998 to that in 2001?
Provide a succinct answer. 0.68. What is the ratio of the Electricity production(% of total) of Zambia in 1998 to that in 2001?
Make the answer very short. 1.6. What is the ratio of the Electricity production(% of total) of Dominican Republic in 1998 to that in 2002?
Offer a very short reply. 0.88. What is the ratio of the Electricity production(% of total) in Japan in 1998 to that in 2002?
Make the answer very short. 0.74. What is the ratio of the Electricity production(% of total) in Tanzania in 1998 to that in 2002?
Provide a short and direct response. 0.59. What is the ratio of the Electricity production(% of total) of Zambia in 1998 to that in 2002?
Offer a terse response. 1.64. What is the ratio of the Electricity production(% of total) of Dominican Republic in 1998 to that in 2003?
Keep it short and to the point. 0.69. What is the ratio of the Electricity production(% of total) of Japan in 1998 to that in 2003?
Ensure brevity in your answer.  0.69. What is the ratio of the Electricity production(% of total) in Tanzania in 1998 to that in 2003?
Offer a terse response. 0.8. What is the ratio of the Electricity production(% of total) of Zambia in 1998 to that in 2003?
Your answer should be very brief. 1.57. What is the ratio of the Electricity production(% of total) of Dominican Republic in 1999 to that in 2000?
Keep it short and to the point. 0.06. What is the ratio of the Electricity production(% of total) of Japan in 1999 to that in 2000?
Provide a succinct answer. 0.93. What is the ratio of the Electricity production(% of total) in Tanzania in 1999 to that in 2000?
Ensure brevity in your answer.  0.9. What is the ratio of the Electricity production(% of total) in Zambia in 1999 to that in 2000?
Your answer should be compact. 1. What is the ratio of the Electricity production(% of total) in Dominican Republic in 1999 to that in 2001?
Offer a very short reply. 0.03. What is the ratio of the Electricity production(% of total) in Japan in 1999 to that in 2001?
Offer a terse response. 0.85. What is the ratio of the Electricity production(% of total) of Tanzania in 1999 to that in 2001?
Provide a succinct answer. 0.75. What is the ratio of the Electricity production(% of total) of Zambia in 1999 to that in 2001?
Your response must be concise. 0.95. What is the ratio of the Electricity production(% of total) in Dominican Republic in 1999 to that in 2002?
Your answer should be compact. 0.03. What is the ratio of the Electricity production(% of total) in Japan in 1999 to that in 2002?
Offer a terse response. 0.81. What is the ratio of the Electricity production(% of total) of Tanzania in 1999 to that in 2002?
Your response must be concise. 0.65. What is the ratio of the Electricity production(% of total) of Dominican Republic in 1999 to that in 2003?
Keep it short and to the point. 0.02. What is the ratio of the Electricity production(% of total) of Japan in 1999 to that in 2003?
Your answer should be very brief. 0.75. What is the ratio of the Electricity production(% of total) of Tanzania in 1999 to that in 2003?
Offer a terse response. 0.88. What is the ratio of the Electricity production(% of total) of Zambia in 1999 to that in 2003?
Your answer should be compact. 0.94. What is the ratio of the Electricity production(% of total) of Dominican Republic in 2000 to that in 2001?
Provide a succinct answer. 0.55. What is the ratio of the Electricity production(% of total) of Japan in 2000 to that in 2001?
Provide a short and direct response. 0.92. What is the ratio of the Electricity production(% of total) of Tanzania in 2000 to that in 2001?
Your answer should be compact. 0.84. What is the ratio of the Electricity production(% of total) in Zambia in 2000 to that in 2001?
Ensure brevity in your answer.  0.95. What is the ratio of the Electricity production(% of total) of Dominican Republic in 2000 to that in 2002?
Provide a short and direct response. 0.49. What is the ratio of the Electricity production(% of total) of Japan in 2000 to that in 2002?
Offer a very short reply. 0.87. What is the ratio of the Electricity production(% of total) of Tanzania in 2000 to that in 2002?
Make the answer very short. 0.73. What is the ratio of the Electricity production(% of total) in Zambia in 2000 to that in 2002?
Offer a terse response. 0.98. What is the ratio of the Electricity production(% of total) of Dominican Republic in 2000 to that in 2003?
Offer a very short reply. 0.39. What is the ratio of the Electricity production(% of total) of Japan in 2000 to that in 2003?
Offer a terse response. 0.81. What is the ratio of the Electricity production(% of total) in Tanzania in 2000 to that in 2003?
Make the answer very short. 0.99. What is the ratio of the Electricity production(% of total) in Zambia in 2000 to that in 2003?
Your answer should be very brief. 0.93. What is the ratio of the Electricity production(% of total) in Dominican Republic in 2001 to that in 2002?
Your answer should be compact. 0.88. What is the ratio of the Electricity production(% of total) of Japan in 2001 to that in 2002?
Your response must be concise. 0.95. What is the ratio of the Electricity production(% of total) of Tanzania in 2001 to that in 2002?
Provide a short and direct response. 0.87. What is the ratio of the Electricity production(% of total) of Zambia in 2001 to that in 2002?
Keep it short and to the point. 1.03. What is the ratio of the Electricity production(% of total) in Dominican Republic in 2001 to that in 2003?
Offer a terse response. 0.7. What is the ratio of the Electricity production(% of total) of Japan in 2001 to that in 2003?
Provide a succinct answer. 0.88. What is the ratio of the Electricity production(% of total) of Tanzania in 2001 to that in 2003?
Keep it short and to the point. 1.18. What is the ratio of the Electricity production(% of total) of Zambia in 2001 to that in 2003?
Offer a terse response. 0.98. What is the ratio of the Electricity production(% of total) in Dominican Republic in 2002 to that in 2003?
Offer a very short reply. 0.79. What is the ratio of the Electricity production(% of total) in Japan in 2002 to that in 2003?
Offer a very short reply. 0.93. What is the ratio of the Electricity production(% of total) of Tanzania in 2002 to that in 2003?
Your response must be concise. 1.35. What is the ratio of the Electricity production(% of total) in Zambia in 2002 to that in 2003?
Offer a terse response. 0.96. What is the difference between the highest and the second highest Electricity production(% of total) of Dominican Republic?
Provide a succinct answer. 1.46. What is the difference between the highest and the second highest Electricity production(% of total) in Japan?
Your answer should be compact. 1.78. What is the difference between the highest and the second highest Electricity production(% of total) in Tanzania?
Your answer should be compact. 0.48. What is the difference between the highest and the lowest Electricity production(% of total) in Dominican Republic?
Keep it short and to the point. 6.88. What is the difference between the highest and the lowest Electricity production(% of total) in Japan?
Keep it short and to the point. 8.3. What is the difference between the highest and the lowest Electricity production(% of total) of Tanzania?
Provide a short and direct response. 1.58. What is the difference between the highest and the lowest Electricity production(% of total) of Zambia?
Provide a short and direct response. 0.12. 